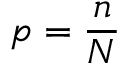Convert formula to latex. <formula><loc_0><loc_0><loc_500><loc_500>p = \frac { n } { N }</formula> 